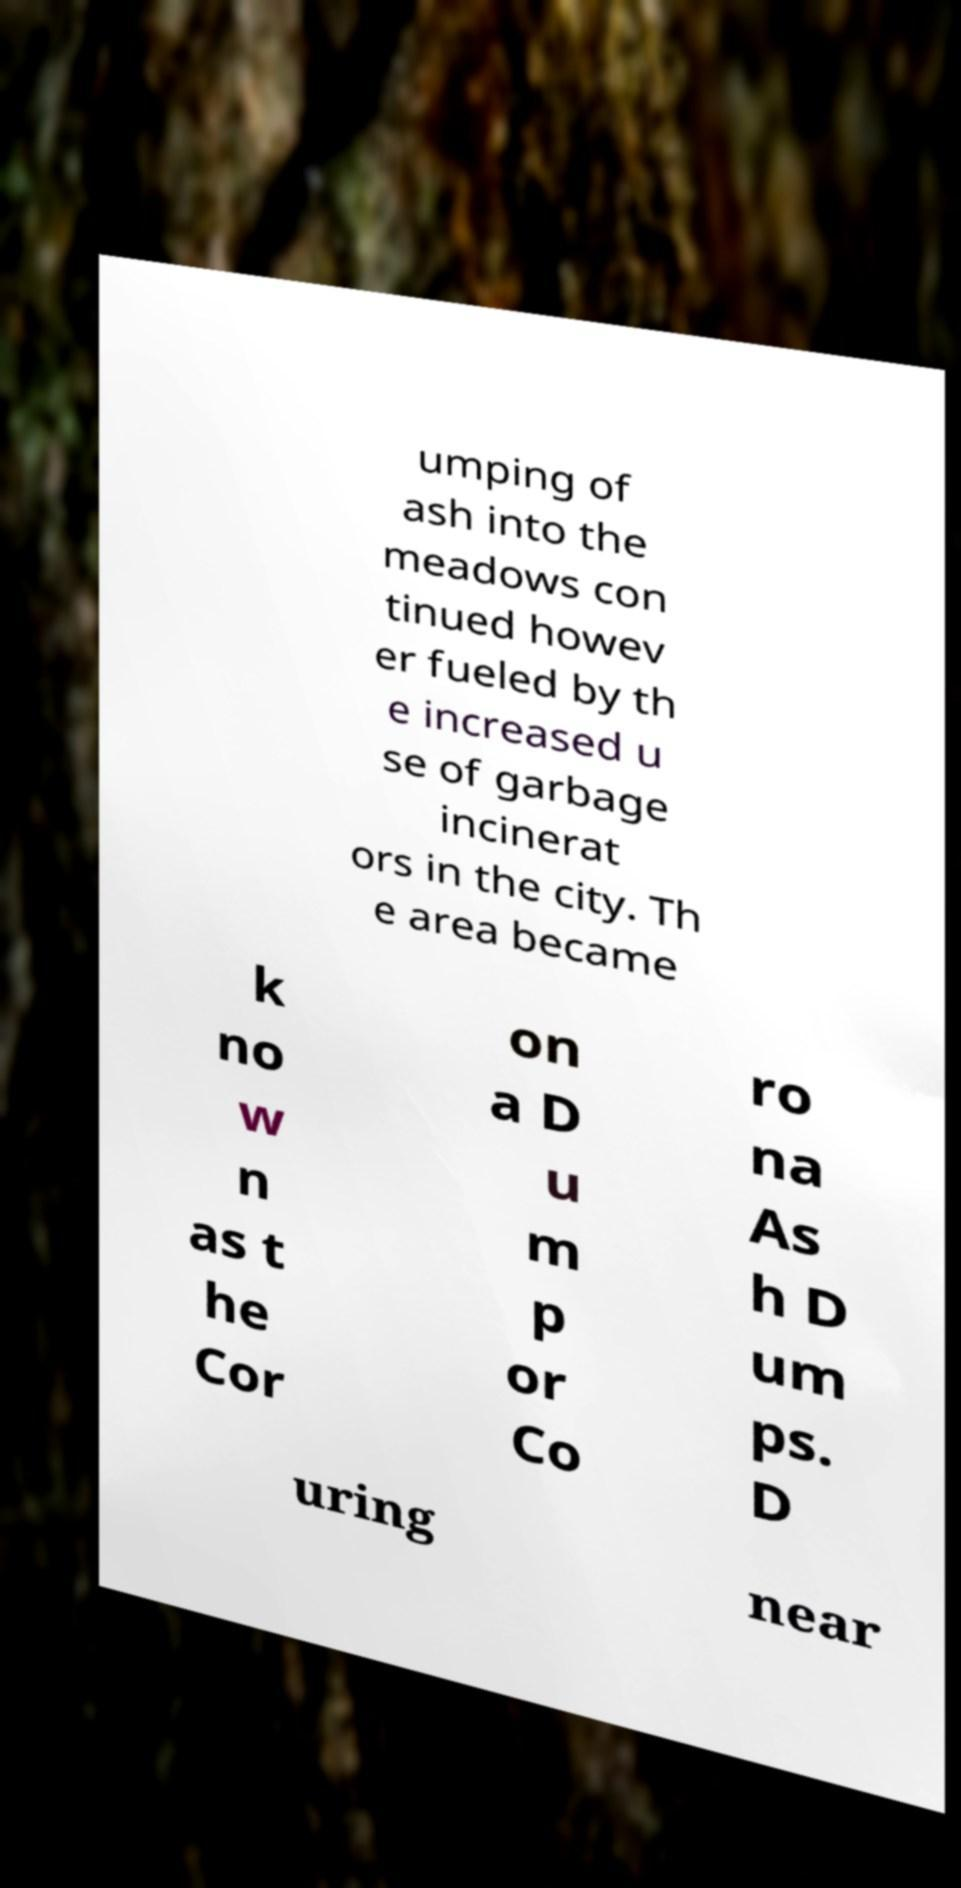Can you accurately transcribe the text from the provided image for me? umping of ash into the meadows con tinued howev er fueled by th e increased u se of garbage incinerat ors in the city. Th e area became k no w n as t he Cor on a D u m p or Co ro na As h D um ps. D uring near 